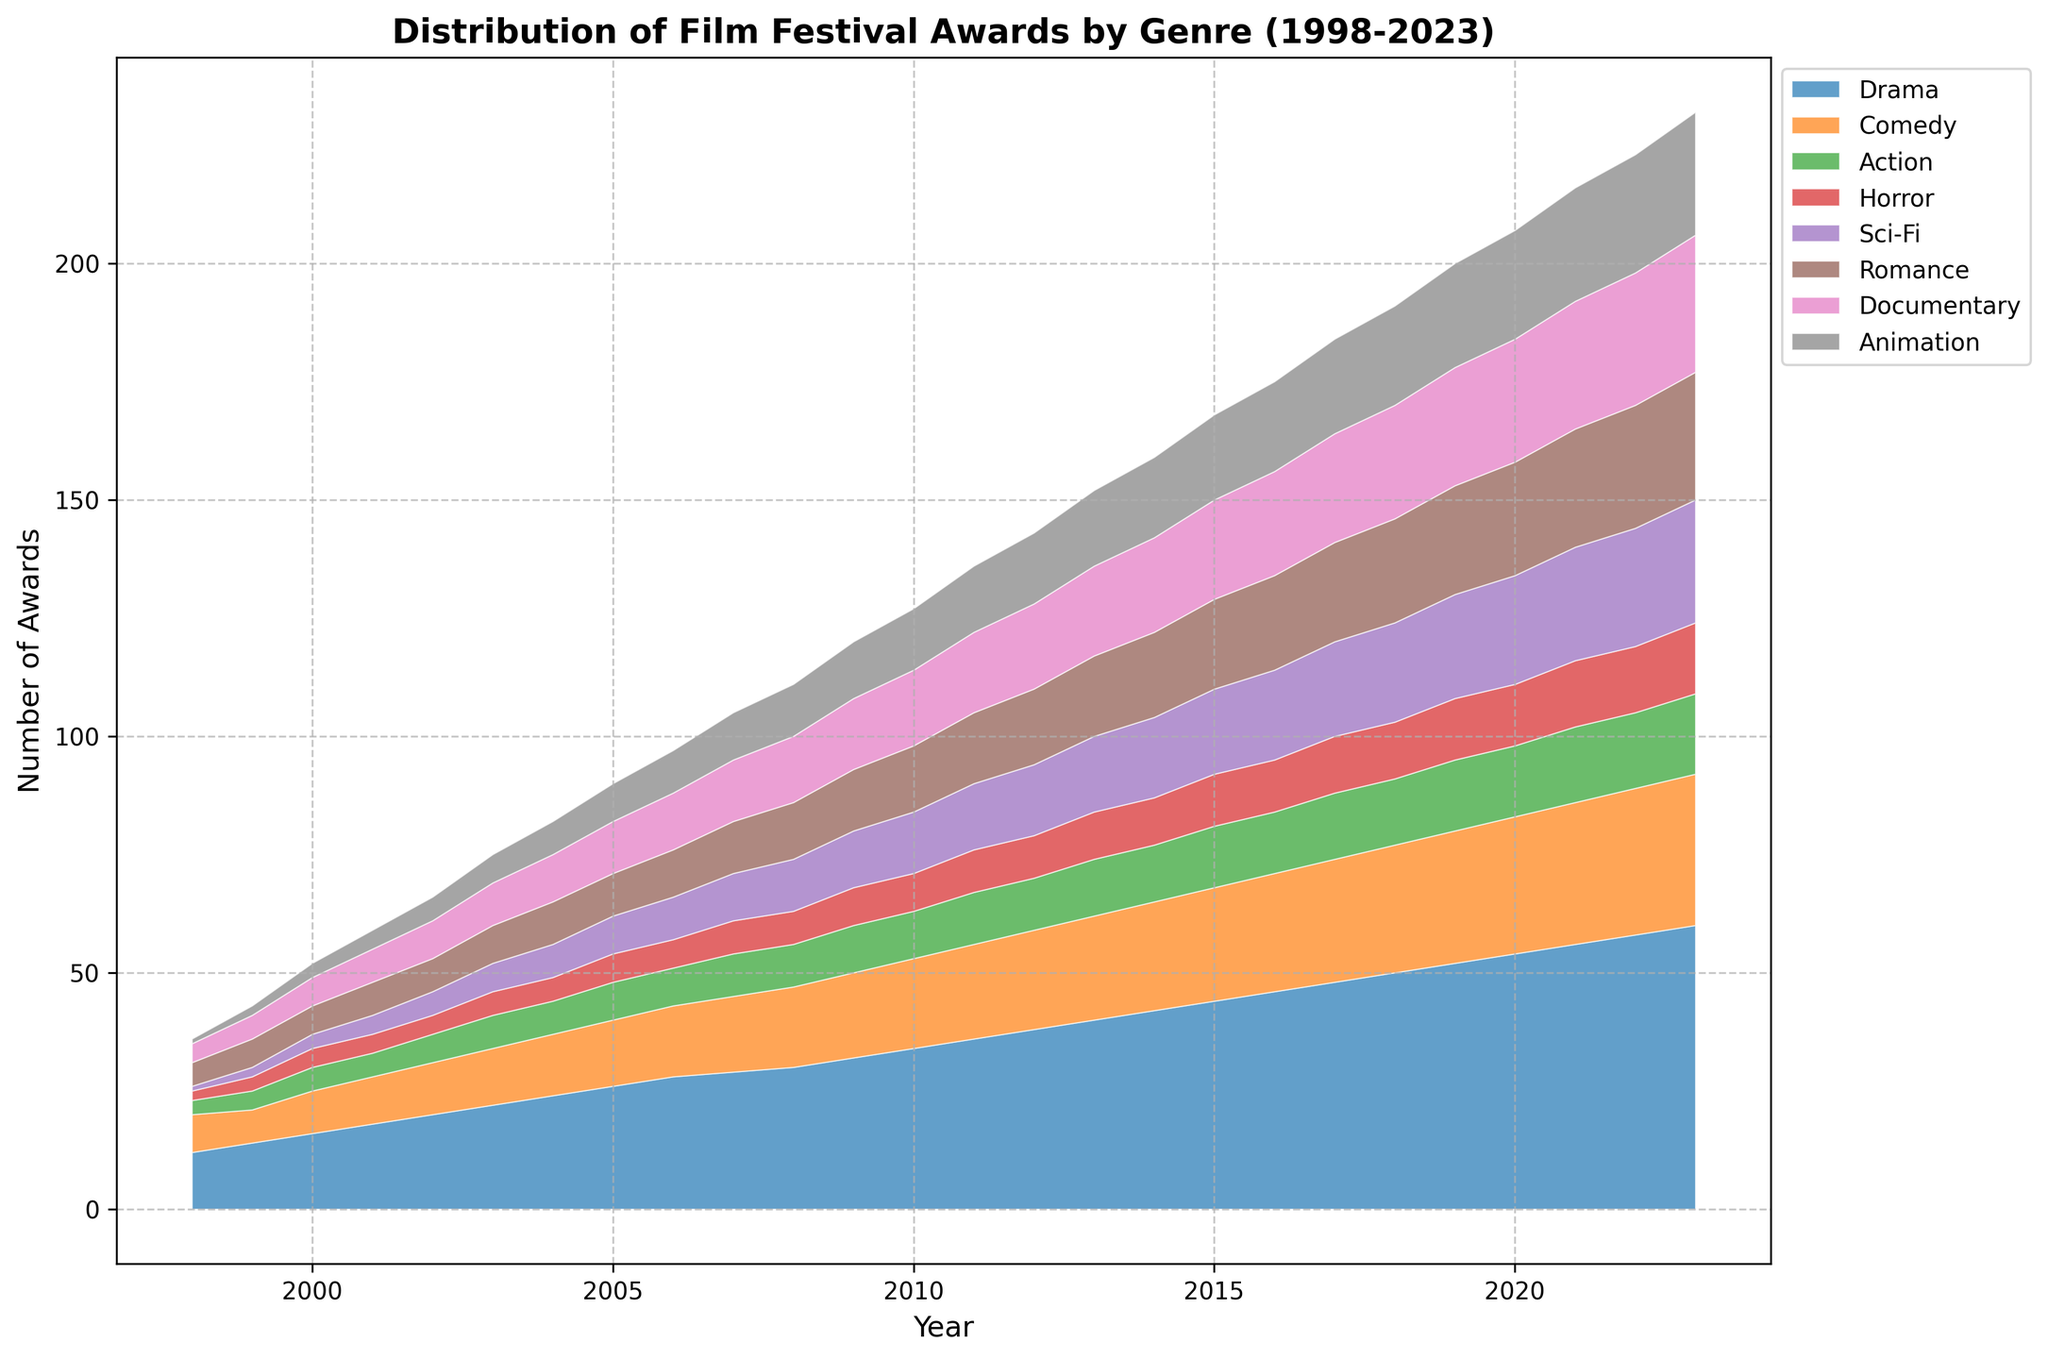What is the general trend for Drama awards over the 25-year period? Looking at the line for Drama, it consistently increases from 12 awards in 1998 to 60 awards in 2023. The trend is a steady upward trajectory.
Answer: Steadily increasing Which genre had the highest increase in the number of awards over the 25 years? To determine the highest increase, we compute the difference in awards from 2023 and 1998 for each genre. Drama had the highest increase (60 - 12 = 48 awards increase).
Answer: Drama In which year did Sci-Fi awards first surpass Horror awards? The plot shows that Sci-Fi surpassed Horror in terms of awards in 2002, where Sci-Fi had 5 awards and Horror remained stable at 4 awards.
Answer: 2002 How does the distribution of awards for Documentary compare to Animation in 2023? In 2023, the stacked area plot shows more total height for Documentary compared to Animation. Documentary had 29 awards while Animation had 26 awards.
Answer: Documentary has more What is the total number of awards given in 2005? Sum the values for all genres in 2005: 26 (Drama) + 14 (Comedy) + 8 (Action) + 6 (Horror) + 8 (Sci-Fi) + 9 (Romance) + 11 (Documentary) + 8 (Animation) = 90.
Answer: 90 Which year shows the highest number of total awards given across all genres, and how many awards were given in that year? To find the total awards given each year, sum the values for all genres in each year. 2023 has the highest total. Calculating for 2023: 60 (Drama) + 32 (Comedy) + 17 (Action) + 15 (Horror) + 26 (Sci-Fi) + 27 (Romance) + 29 (Documentary) + 26 (Animation) = 232.
Answer: 2023, 232 Compare the number of Comedy awards to Horror awards in the year 2010. For the year 2010, Comedy received 19 awards while Horror received 8 awards. So, Comedy had significantly more awards than Horror.
Answer: Comedy has more Between which consecutive years did Romance awards see the largest increase? Calculate the difference in Romance awards between consecutive years, the largest year-to-year increase occurs from 2019 to 2020, where it went from 23 to 24, a 1 award increase.
Answer: 2019-2020 Which genre saw the least change in the number of awards over the years? By observing the slopes, Action has a relatively smaller and steadier increase compared to others. Its change from 3 in 1998 to 17 in 2023 is 14 awards, which is the least change among the genres.
Answer: Action 